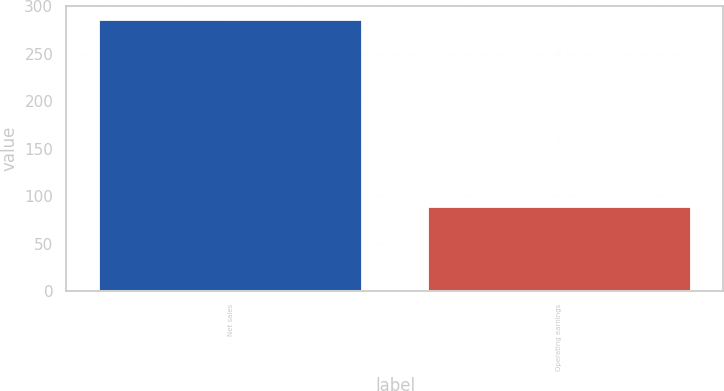Convert chart to OTSL. <chart><loc_0><loc_0><loc_500><loc_500><bar_chart><fcel>Net sales<fcel>Operating earnings<nl><fcel>286<fcel>89<nl></chart> 